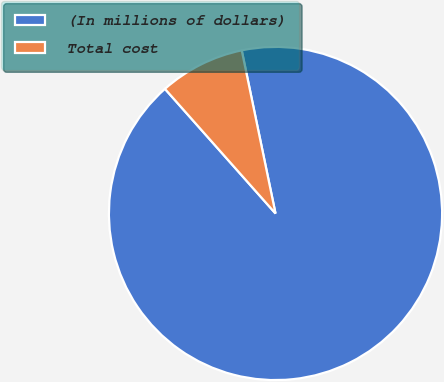Convert chart to OTSL. <chart><loc_0><loc_0><loc_500><loc_500><pie_chart><fcel>(In millions of dollars)<fcel>Total cost<nl><fcel>91.7%<fcel>8.3%<nl></chart> 